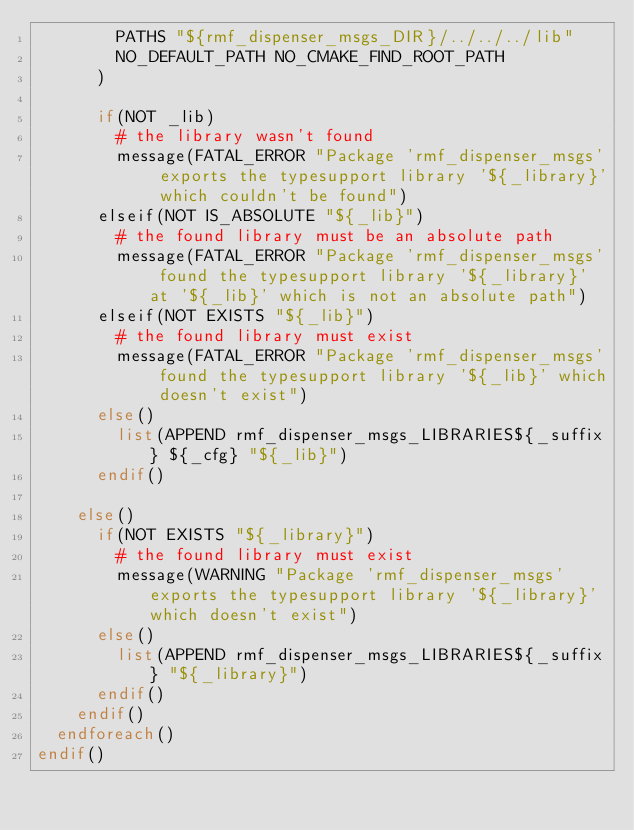<code> <loc_0><loc_0><loc_500><loc_500><_CMake_>        PATHS "${rmf_dispenser_msgs_DIR}/../../../lib"
        NO_DEFAULT_PATH NO_CMAKE_FIND_ROOT_PATH
      )

      if(NOT _lib)
        # the library wasn't found
        message(FATAL_ERROR "Package 'rmf_dispenser_msgs' exports the typesupport library '${_library}' which couldn't be found")
      elseif(NOT IS_ABSOLUTE "${_lib}")
        # the found library must be an absolute path
        message(FATAL_ERROR "Package 'rmf_dispenser_msgs' found the typesupport library '${_library}' at '${_lib}' which is not an absolute path")
      elseif(NOT EXISTS "${_lib}")
        # the found library must exist
        message(FATAL_ERROR "Package 'rmf_dispenser_msgs' found the typesupport library '${_lib}' which doesn't exist")
      else()
        list(APPEND rmf_dispenser_msgs_LIBRARIES${_suffix} ${_cfg} "${_lib}")
      endif()

    else()
      if(NOT EXISTS "${_library}")
        # the found library must exist
        message(WARNING "Package 'rmf_dispenser_msgs' exports the typesupport library '${_library}' which doesn't exist")
      else()
        list(APPEND rmf_dispenser_msgs_LIBRARIES${_suffix} "${_library}")
      endif()
    endif()
  endforeach()
endif()
</code> 